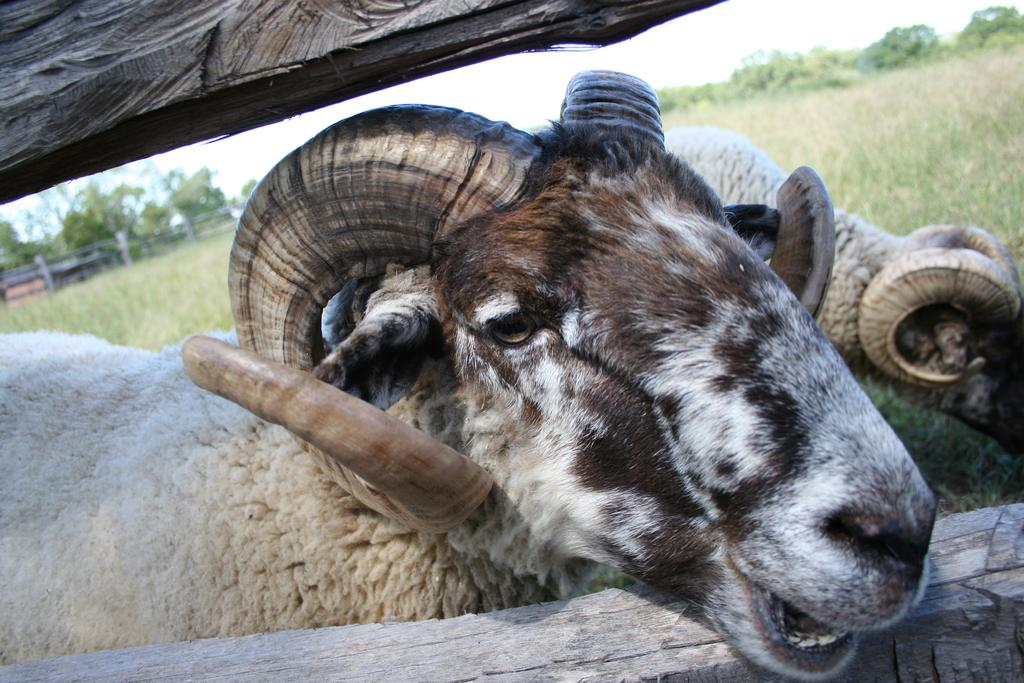What animals are present in the image? There are bighorn sheep in the image. What type of vegetation can be seen in the background of the image? There is grass in the background of the image. What else can be seen in the background of the image? There are trees and a wooden fence in the background of the image. What is visible in the sky in the image? The sky is visible in the background of the image. What type of bone is being used as a paperweight by the secretary in the image? There is no secretary or bone present in the image; it features bighorn sheep in a natural setting. What is the air quality like in the image? The provided facts do not give information about the air quality in the image. 